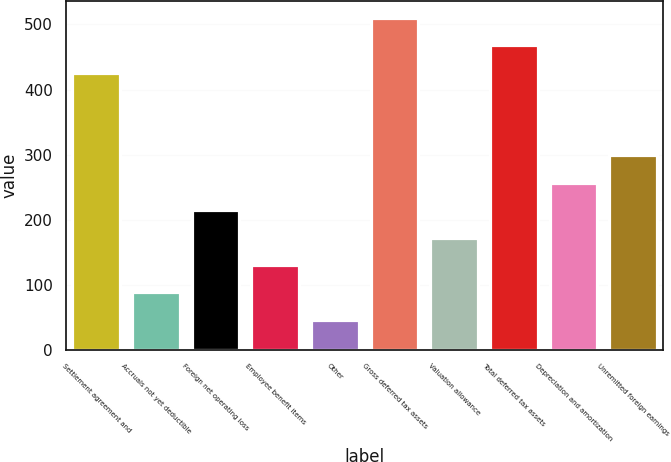Convert chart to OTSL. <chart><loc_0><loc_0><loc_500><loc_500><bar_chart><fcel>Settlement agreement and<fcel>Accruals not yet deductible<fcel>Foreign net operating loss<fcel>Employee benefit items<fcel>Other<fcel>Gross deferred tax assets<fcel>Valuation allowance<fcel>Total deferred tax assets<fcel>Depreciation and amortization<fcel>Unremitted foreign earnings<nl><fcel>425.8<fcel>88.04<fcel>214.7<fcel>130.26<fcel>45.82<fcel>510.24<fcel>172.48<fcel>468.02<fcel>256.92<fcel>299.14<nl></chart> 